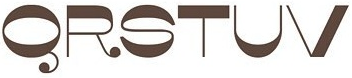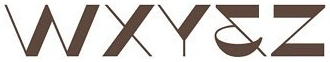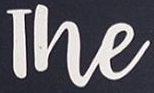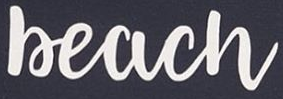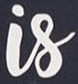What text appears in these images from left to right, separated by a semicolon? QRSTUV; WXY&Z; The; Beach; Is 